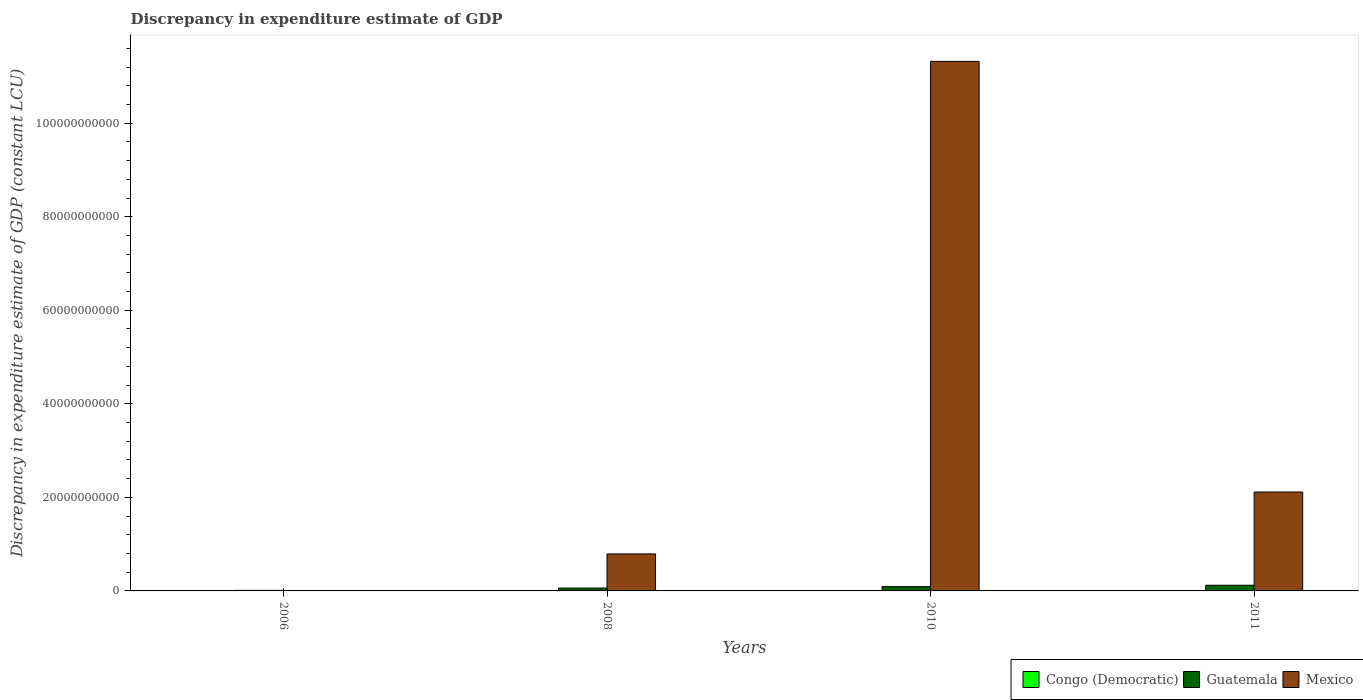How many different coloured bars are there?
Your answer should be compact. 2. Are the number of bars on each tick of the X-axis equal?
Your answer should be very brief. No. How many bars are there on the 3rd tick from the left?
Make the answer very short. 2. In how many cases, is the number of bars for a given year not equal to the number of legend labels?
Keep it short and to the point. 4. What is the discrepancy in expenditure estimate of GDP in Mexico in 2010?
Offer a very short reply. 1.13e+11. Across all years, what is the maximum discrepancy in expenditure estimate of GDP in Mexico?
Your answer should be compact. 1.13e+11. What is the total discrepancy in expenditure estimate of GDP in Guatemala in the graph?
Offer a very short reply. 2.86e+09. What is the difference between the discrepancy in expenditure estimate of GDP in Guatemala in 2010 and that in 2011?
Provide a succinct answer. -2.99e+08. What is the difference between the discrepancy in expenditure estimate of GDP in Guatemala in 2011 and the discrepancy in expenditure estimate of GDP in Mexico in 2010?
Offer a terse response. -1.12e+11. What is the average discrepancy in expenditure estimate of GDP in Mexico per year?
Your answer should be compact. 3.56e+1. In the year 2010, what is the difference between the discrepancy in expenditure estimate of GDP in Guatemala and discrepancy in expenditure estimate of GDP in Mexico?
Provide a short and direct response. -1.12e+11. In how many years, is the discrepancy in expenditure estimate of GDP in Guatemala greater than 44000000000 LCU?
Offer a very short reply. 0. What is the ratio of the discrepancy in expenditure estimate of GDP in Guatemala in 2010 to that in 2011?
Keep it short and to the point. 0.75. Is the discrepancy in expenditure estimate of GDP in Mexico in 2008 less than that in 2010?
Your answer should be very brief. Yes. Is the difference between the discrepancy in expenditure estimate of GDP in Guatemala in 2008 and 2010 greater than the difference between the discrepancy in expenditure estimate of GDP in Mexico in 2008 and 2010?
Your answer should be very brief. Yes. What is the difference between the highest and the second highest discrepancy in expenditure estimate of GDP in Mexico?
Make the answer very short. 9.21e+1. What is the difference between the highest and the lowest discrepancy in expenditure estimate of GDP in Guatemala?
Make the answer very short. 1.10e+09. Is the sum of the discrepancy in expenditure estimate of GDP in Guatemala in 2008 and 2010 greater than the maximum discrepancy in expenditure estimate of GDP in Mexico across all years?
Provide a succinct answer. No. Is it the case that in every year, the sum of the discrepancy in expenditure estimate of GDP in Congo (Democratic) and discrepancy in expenditure estimate of GDP in Guatemala is greater than the discrepancy in expenditure estimate of GDP in Mexico?
Provide a short and direct response. No. How many bars are there?
Ensure brevity in your answer.  7. How many years are there in the graph?
Make the answer very short. 4. Are the values on the major ticks of Y-axis written in scientific E-notation?
Give a very brief answer. No. Does the graph contain any zero values?
Keep it short and to the point. Yes. Does the graph contain grids?
Your response must be concise. No. Where does the legend appear in the graph?
Your response must be concise. Bottom right. What is the title of the graph?
Offer a terse response. Discrepancy in expenditure estimate of GDP. Does "Thailand" appear as one of the legend labels in the graph?
Your answer should be compact. No. What is the label or title of the X-axis?
Ensure brevity in your answer.  Years. What is the label or title of the Y-axis?
Make the answer very short. Discrepancy in expenditure estimate of GDP (constant LCU). What is the Discrepancy in expenditure estimate of GDP (constant LCU) of Guatemala in 2006?
Provide a short and direct response. 1.20e+08. What is the Discrepancy in expenditure estimate of GDP (constant LCU) of Mexico in 2006?
Your answer should be compact. 0. What is the Discrepancy in expenditure estimate of GDP (constant LCU) of Congo (Democratic) in 2008?
Offer a terse response. 0. What is the Discrepancy in expenditure estimate of GDP (constant LCU) of Guatemala in 2008?
Give a very brief answer. 6.12e+08. What is the Discrepancy in expenditure estimate of GDP (constant LCU) in Mexico in 2008?
Your response must be concise. 7.91e+09. What is the Discrepancy in expenditure estimate of GDP (constant LCU) in Congo (Democratic) in 2010?
Your answer should be very brief. 0. What is the Discrepancy in expenditure estimate of GDP (constant LCU) in Guatemala in 2010?
Provide a succinct answer. 9.16e+08. What is the Discrepancy in expenditure estimate of GDP (constant LCU) in Mexico in 2010?
Make the answer very short. 1.13e+11. What is the Discrepancy in expenditure estimate of GDP (constant LCU) in Congo (Democratic) in 2011?
Offer a terse response. 0. What is the Discrepancy in expenditure estimate of GDP (constant LCU) of Guatemala in 2011?
Offer a very short reply. 1.22e+09. What is the Discrepancy in expenditure estimate of GDP (constant LCU) of Mexico in 2011?
Give a very brief answer. 2.11e+1. Across all years, what is the maximum Discrepancy in expenditure estimate of GDP (constant LCU) of Guatemala?
Your answer should be very brief. 1.22e+09. Across all years, what is the maximum Discrepancy in expenditure estimate of GDP (constant LCU) in Mexico?
Ensure brevity in your answer.  1.13e+11. Across all years, what is the minimum Discrepancy in expenditure estimate of GDP (constant LCU) of Guatemala?
Provide a succinct answer. 1.20e+08. Across all years, what is the minimum Discrepancy in expenditure estimate of GDP (constant LCU) in Mexico?
Ensure brevity in your answer.  0. What is the total Discrepancy in expenditure estimate of GDP (constant LCU) of Guatemala in the graph?
Provide a succinct answer. 2.86e+09. What is the total Discrepancy in expenditure estimate of GDP (constant LCU) in Mexico in the graph?
Provide a succinct answer. 1.42e+11. What is the difference between the Discrepancy in expenditure estimate of GDP (constant LCU) of Guatemala in 2006 and that in 2008?
Ensure brevity in your answer.  -4.92e+08. What is the difference between the Discrepancy in expenditure estimate of GDP (constant LCU) of Guatemala in 2006 and that in 2010?
Provide a succinct answer. -7.96e+08. What is the difference between the Discrepancy in expenditure estimate of GDP (constant LCU) in Guatemala in 2006 and that in 2011?
Keep it short and to the point. -1.10e+09. What is the difference between the Discrepancy in expenditure estimate of GDP (constant LCU) in Guatemala in 2008 and that in 2010?
Provide a short and direct response. -3.04e+08. What is the difference between the Discrepancy in expenditure estimate of GDP (constant LCU) of Mexico in 2008 and that in 2010?
Provide a succinct answer. -1.05e+11. What is the difference between the Discrepancy in expenditure estimate of GDP (constant LCU) of Guatemala in 2008 and that in 2011?
Offer a terse response. -6.03e+08. What is the difference between the Discrepancy in expenditure estimate of GDP (constant LCU) of Mexico in 2008 and that in 2011?
Your answer should be compact. -1.32e+1. What is the difference between the Discrepancy in expenditure estimate of GDP (constant LCU) in Guatemala in 2010 and that in 2011?
Provide a succinct answer. -2.99e+08. What is the difference between the Discrepancy in expenditure estimate of GDP (constant LCU) in Mexico in 2010 and that in 2011?
Your answer should be compact. 9.21e+1. What is the difference between the Discrepancy in expenditure estimate of GDP (constant LCU) of Guatemala in 2006 and the Discrepancy in expenditure estimate of GDP (constant LCU) of Mexico in 2008?
Offer a terse response. -7.79e+09. What is the difference between the Discrepancy in expenditure estimate of GDP (constant LCU) in Guatemala in 2006 and the Discrepancy in expenditure estimate of GDP (constant LCU) in Mexico in 2010?
Your answer should be compact. -1.13e+11. What is the difference between the Discrepancy in expenditure estimate of GDP (constant LCU) in Guatemala in 2006 and the Discrepancy in expenditure estimate of GDP (constant LCU) in Mexico in 2011?
Your answer should be very brief. -2.10e+1. What is the difference between the Discrepancy in expenditure estimate of GDP (constant LCU) of Guatemala in 2008 and the Discrepancy in expenditure estimate of GDP (constant LCU) of Mexico in 2010?
Your response must be concise. -1.13e+11. What is the difference between the Discrepancy in expenditure estimate of GDP (constant LCU) of Guatemala in 2008 and the Discrepancy in expenditure estimate of GDP (constant LCU) of Mexico in 2011?
Offer a very short reply. -2.05e+1. What is the difference between the Discrepancy in expenditure estimate of GDP (constant LCU) in Guatemala in 2010 and the Discrepancy in expenditure estimate of GDP (constant LCU) in Mexico in 2011?
Provide a short and direct response. -2.02e+1. What is the average Discrepancy in expenditure estimate of GDP (constant LCU) in Congo (Democratic) per year?
Provide a short and direct response. 0. What is the average Discrepancy in expenditure estimate of GDP (constant LCU) of Guatemala per year?
Your response must be concise. 7.16e+08. What is the average Discrepancy in expenditure estimate of GDP (constant LCU) of Mexico per year?
Keep it short and to the point. 3.56e+1. In the year 2008, what is the difference between the Discrepancy in expenditure estimate of GDP (constant LCU) of Guatemala and Discrepancy in expenditure estimate of GDP (constant LCU) of Mexico?
Give a very brief answer. -7.30e+09. In the year 2010, what is the difference between the Discrepancy in expenditure estimate of GDP (constant LCU) of Guatemala and Discrepancy in expenditure estimate of GDP (constant LCU) of Mexico?
Make the answer very short. -1.12e+11. In the year 2011, what is the difference between the Discrepancy in expenditure estimate of GDP (constant LCU) in Guatemala and Discrepancy in expenditure estimate of GDP (constant LCU) in Mexico?
Offer a terse response. -1.99e+1. What is the ratio of the Discrepancy in expenditure estimate of GDP (constant LCU) of Guatemala in 2006 to that in 2008?
Offer a very short reply. 0.2. What is the ratio of the Discrepancy in expenditure estimate of GDP (constant LCU) of Guatemala in 2006 to that in 2010?
Provide a succinct answer. 0.13. What is the ratio of the Discrepancy in expenditure estimate of GDP (constant LCU) of Guatemala in 2006 to that in 2011?
Provide a succinct answer. 0.1. What is the ratio of the Discrepancy in expenditure estimate of GDP (constant LCU) in Guatemala in 2008 to that in 2010?
Give a very brief answer. 0.67. What is the ratio of the Discrepancy in expenditure estimate of GDP (constant LCU) of Mexico in 2008 to that in 2010?
Provide a short and direct response. 0.07. What is the ratio of the Discrepancy in expenditure estimate of GDP (constant LCU) in Guatemala in 2008 to that in 2011?
Provide a succinct answer. 0.5. What is the ratio of the Discrepancy in expenditure estimate of GDP (constant LCU) in Mexico in 2008 to that in 2011?
Give a very brief answer. 0.37. What is the ratio of the Discrepancy in expenditure estimate of GDP (constant LCU) in Guatemala in 2010 to that in 2011?
Provide a short and direct response. 0.75. What is the ratio of the Discrepancy in expenditure estimate of GDP (constant LCU) in Mexico in 2010 to that in 2011?
Ensure brevity in your answer.  5.35. What is the difference between the highest and the second highest Discrepancy in expenditure estimate of GDP (constant LCU) in Guatemala?
Offer a very short reply. 2.99e+08. What is the difference between the highest and the second highest Discrepancy in expenditure estimate of GDP (constant LCU) in Mexico?
Provide a succinct answer. 9.21e+1. What is the difference between the highest and the lowest Discrepancy in expenditure estimate of GDP (constant LCU) of Guatemala?
Offer a terse response. 1.10e+09. What is the difference between the highest and the lowest Discrepancy in expenditure estimate of GDP (constant LCU) in Mexico?
Ensure brevity in your answer.  1.13e+11. 